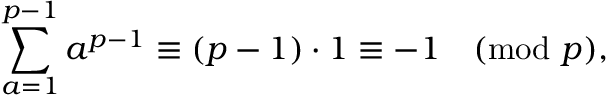Convert formula to latex. <formula><loc_0><loc_0><loc_500><loc_500>\sum _ { a = 1 } ^ { p - 1 } a ^ { p - 1 } \equiv ( p - 1 ) \cdot 1 \equiv - 1 { \pmod { p } } ,</formula> 